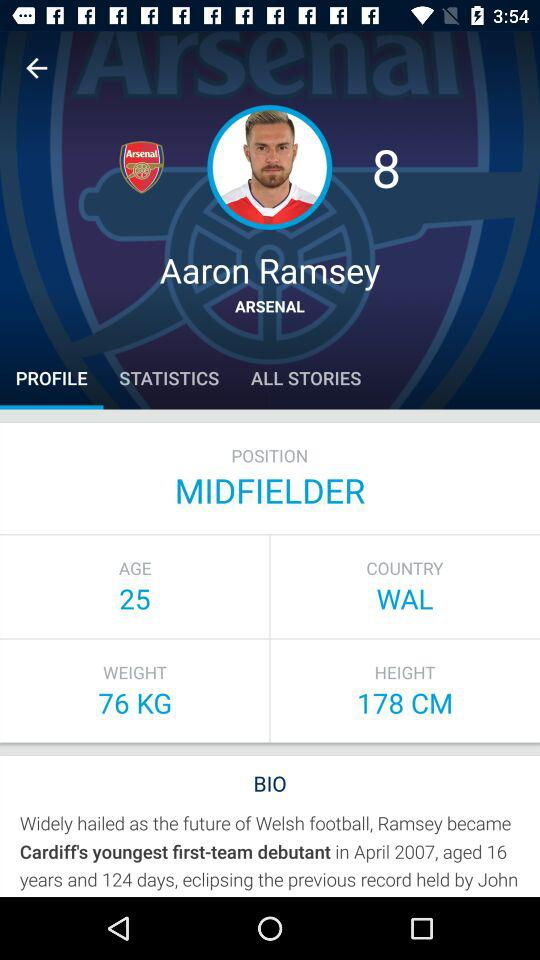How many more years is Ramsey older than he was when he became Cardiff's youngest first-team debutant?
Answer the question using a single word or phrase. 9 